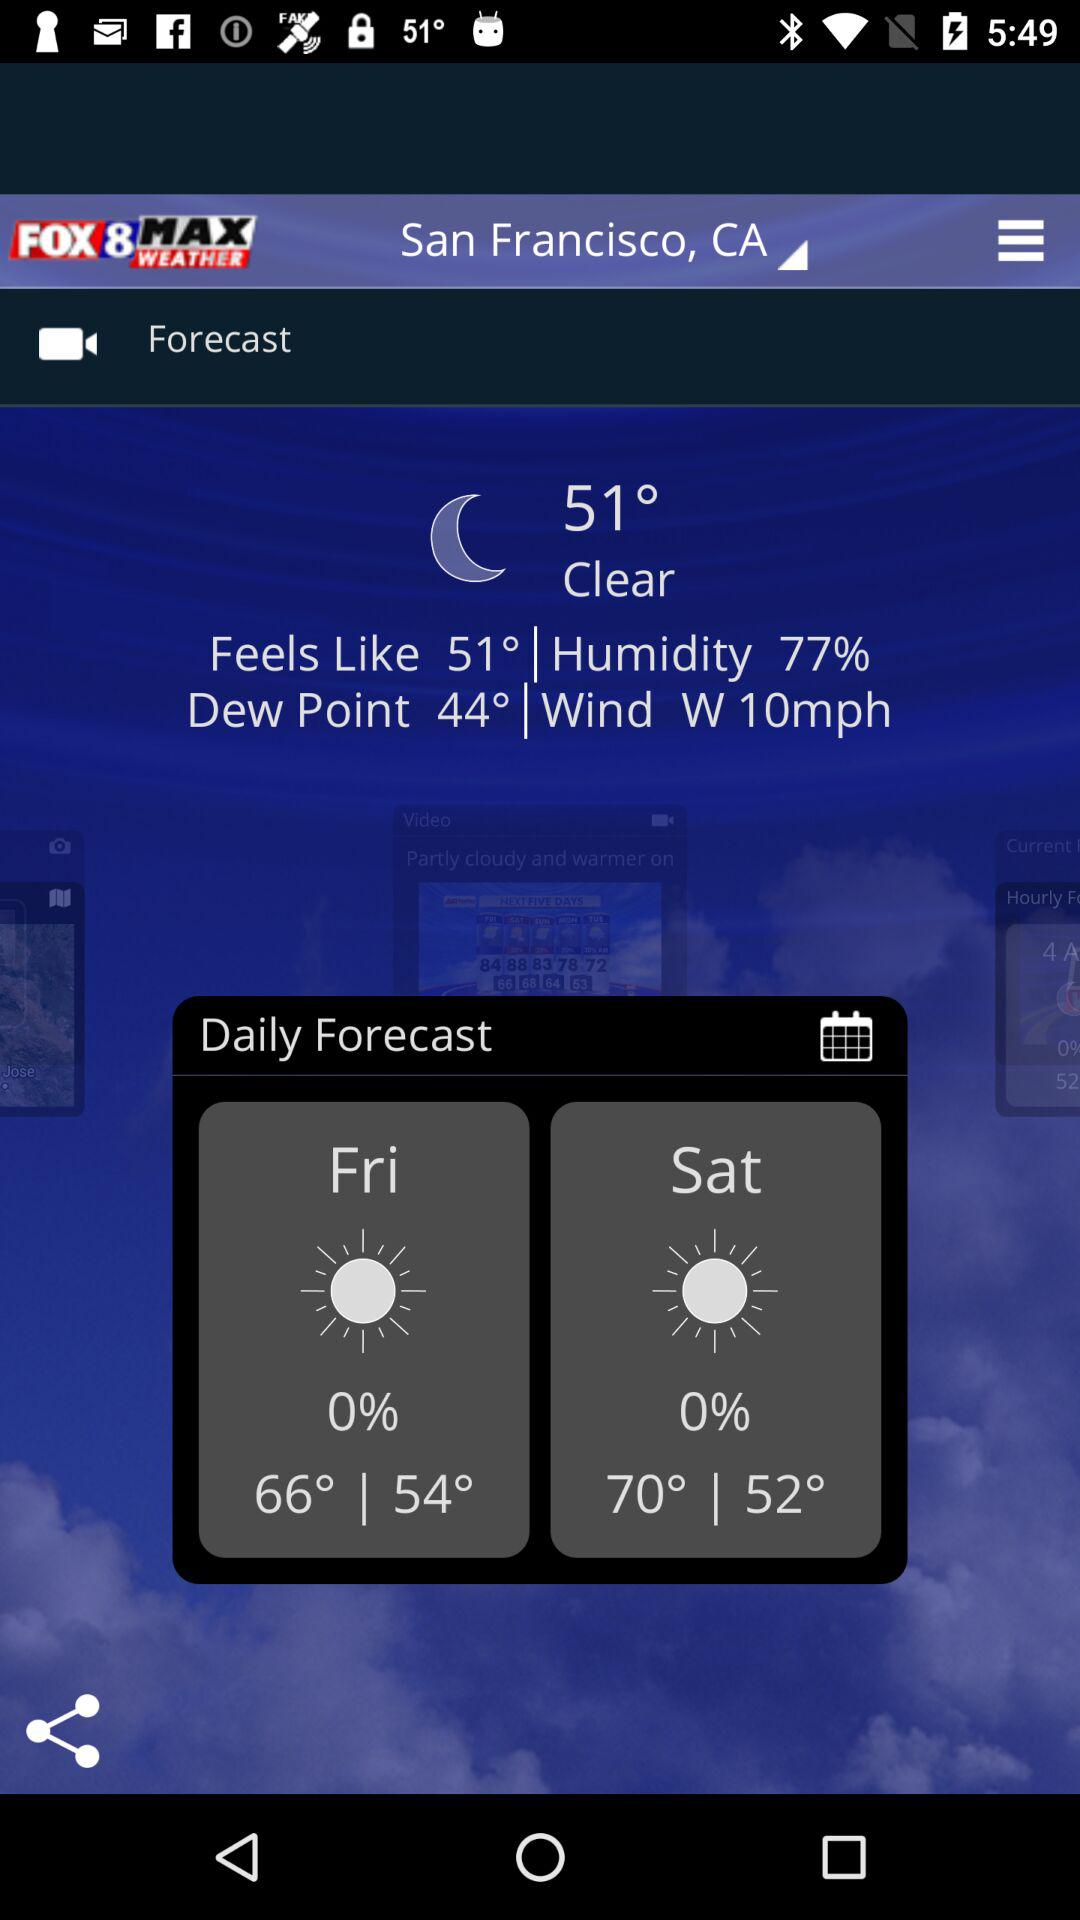How much humidity is there in the air? There is 77% humidity in the air. 